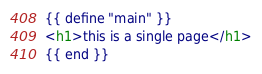Convert code to text. <code><loc_0><loc_0><loc_500><loc_500><_HTML_>{{ define "main" }}
<h1>this is a single page</h1>
{{ end }}
</code> 